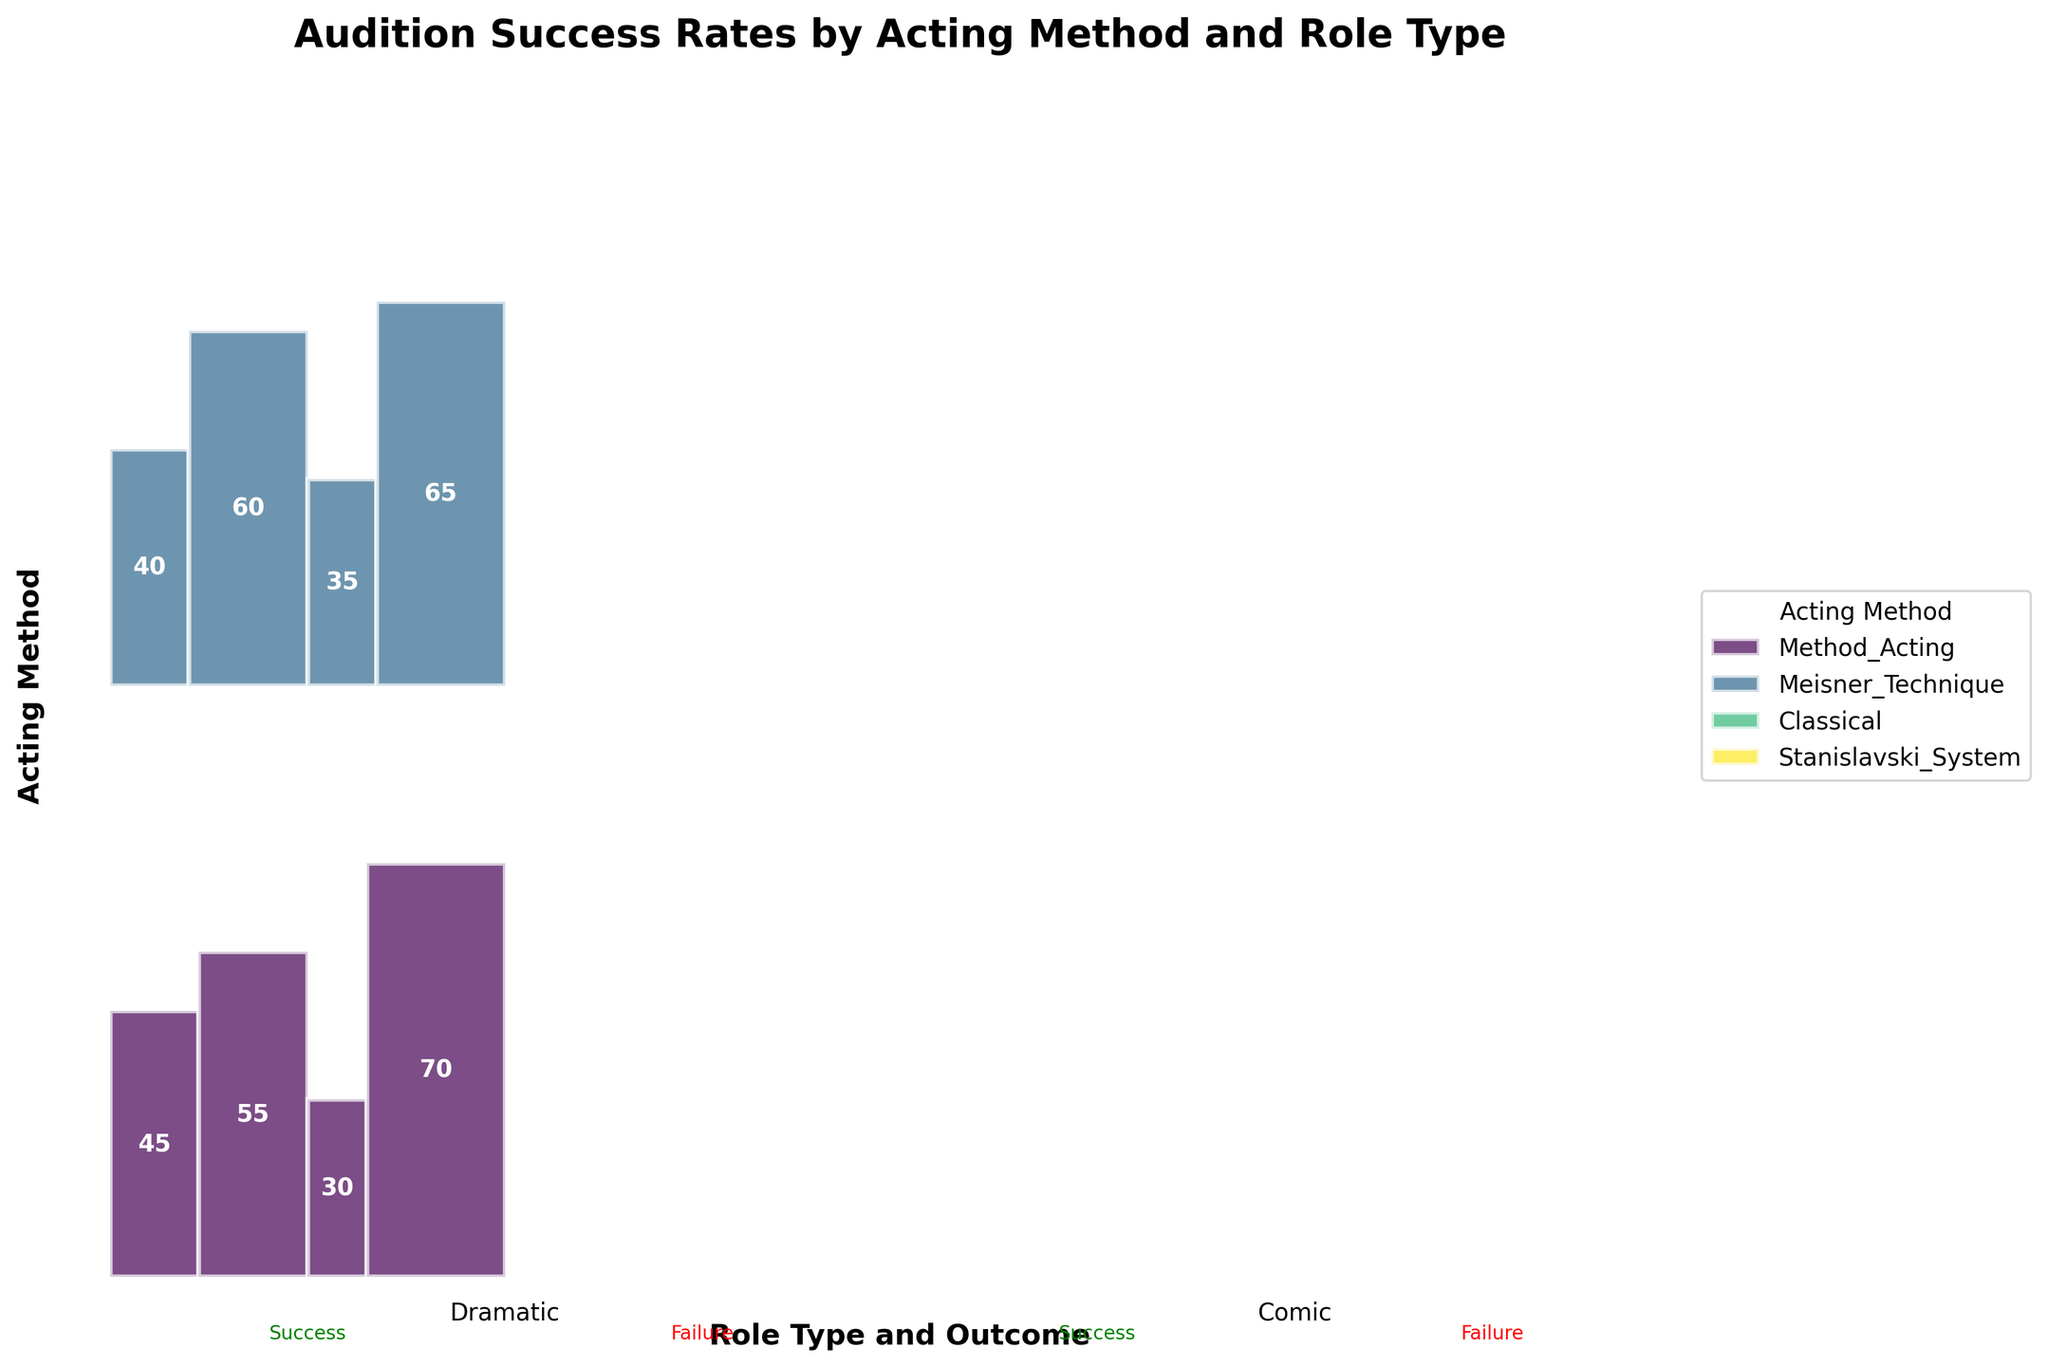What's the title of the plot? The title of the plot is typically found at the top of the figure. It reads, "Audition Success Rates by Acting Method and Role Type."
Answer: Audition Success Rates by Acting Method and Role Type Which acting method has the highest success rate for dramatic roles? To find the highest success rate for dramatic roles, look at the proportion of green (success) boxes related to dramatic roles for each acting method. The Stanislavski System has the highest number of successes for dramatic roles (55).
Answer: Stanislavski System How many performances had a successful audition for comedy roles using the Meisner Technique? To find this, locate the segment that intersects at Meisner Technique and Comedy Success in the plot. This intersection shows '35'.
Answer: 35 Which role type had more success in auditions using Method Acting, Dramatic or Comic? For this, compare the size of the success sections for dramatic and comic roles under Method Acting. Dramatic has 45 successes, and Comic has 30. Therefore, Dramatic has more success.
Answer: Dramatic Compare the success rates of Classical acting for both dramatic and comic roles. Which has a higher success rate? To find the higher success rate for Classical acting, compare the size of the green sections (success) for both dramatic and comic roles. Classical acting has 50 successes in dramatic roles and 25 in comic roles. Therefore, dramatic roles have a higher success rate.
Answer: Dramatic What is the total number of successful auditions across all acting methods for comic roles? To find this, sum the success counts for comic roles across all acting methods. Method Acting (30) + Meisner Technique (35) + Classical (25) + Stanislavski System (40) = 130 successful auditions for comic roles.
Answer: 130 How does the percentage of failures in auditions for dramatic roles compare between Method Acting and the Meisner Technique? Calculate the percentage of failures in dramatic roles for each technique by dividing the number of failures by the total number of auditions in that category. Method Acting has 55 failures out of 100 auditions (55%), and Meisner Technique has 60 failures out of 100 auditions (60%).
Answer: Meisner Technique has a higher percentage In the Stanislavski System, which role type has a closer balance between success and failure rates? Observe the green (success) and red (failure) sections size for dramatic and comic roles within the Stanislavski System. Dramatic roles have 55 successes and 45 failures, closer to a balance than comic roles with 40 successes and 60 failures.
Answer: Dramatic Is there any acting method where the number of successes and failures is equal for any role type? Look for any role within any acting method that has equal green (success) and red (failure) sections. Classical acting for dramatic roles shows 50 successes and 50 failures.
Answer: Yes, in Classical acting for dramatic roles 